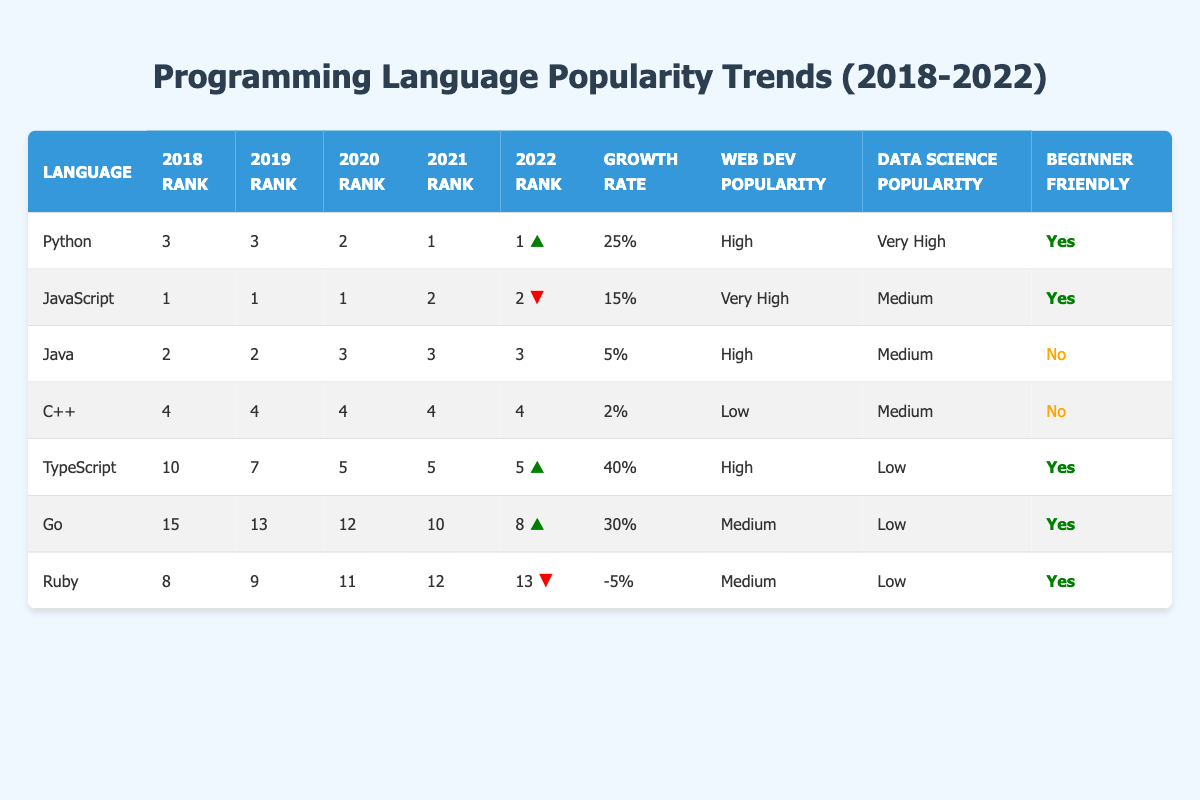What was the rank of Python in 2022? The table states that Python was ranked 1 in 2022.
Answer: 1 Which programming language has the highest growth rate? By comparing the growth rates, TypeScript has a growth rate of 40%, which is the highest among all listed languages.
Answer: TypeScript Was Ruby beginner-friendly? The table indicates that Ruby is marked as beginner-friendly.
Answer: Yes How much did JavaScript's rank drop from 2020 to 2021? JavaScript was ranked 1 in 2020 and dropped to rank 2 in 2021. The difference in rank is 1.
Answer: 1 What is the average growth rate of the top three programming languages? The top three languages (Python, JavaScript, and Java) have growth rates of 25%, 15%, and 5%, respectively. The average is calculated as (25 + 15 + 5) / 3 = 15%.
Answer: 15% Which programming language had a decrease in both rank and growth rate between 2018 and 2022? Ruby's rank decreased from 8 in 2018 to 13 in 2022, and it also had a negative growth rate of -5%.
Answer: Ruby What was the rank of Go in 2020? The table shows that Go was ranked 12 in 2020.
Answer: 12 How many languages have a high popularity in web development? From the table, Python, JavaScript, and TypeScript all have high popularity in web development, making a total of 3 languages.
Answer: 3 What was the rank change for C++ from 2018 to 2022? C++ maintained its rank of 4 throughout the years from 2018 to 2022, indicating no change in rank.
Answer: No change 